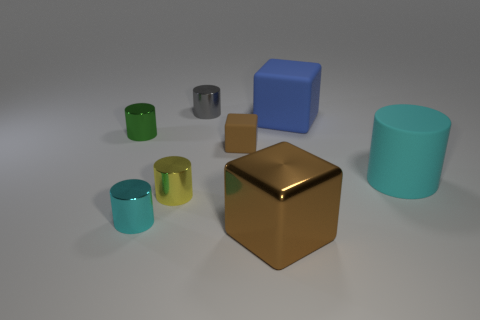Subtract 2 cylinders. How many cylinders are left? 3 Subtract all matte cylinders. How many cylinders are left? 4 Subtract all gray cylinders. How many cylinders are left? 4 Subtract all green cylinders. Subtract all blue balls. How many cylinders are left? 4 Add 2 tiny shiny cylinders. How many objects exist? 10 Subtract all blocks. How many objects are left? 5 Add 4 red matte things. How many red matte things exist? 4 Subtract 0 purple cylinders. How many objects are left? 8 Subtract all big green rubber balls. Subtract all small gray cylinders. How many objects are left? 7 Add 5 cyan shiny cylinders. How many cyan shiny cylinders are left? 6 